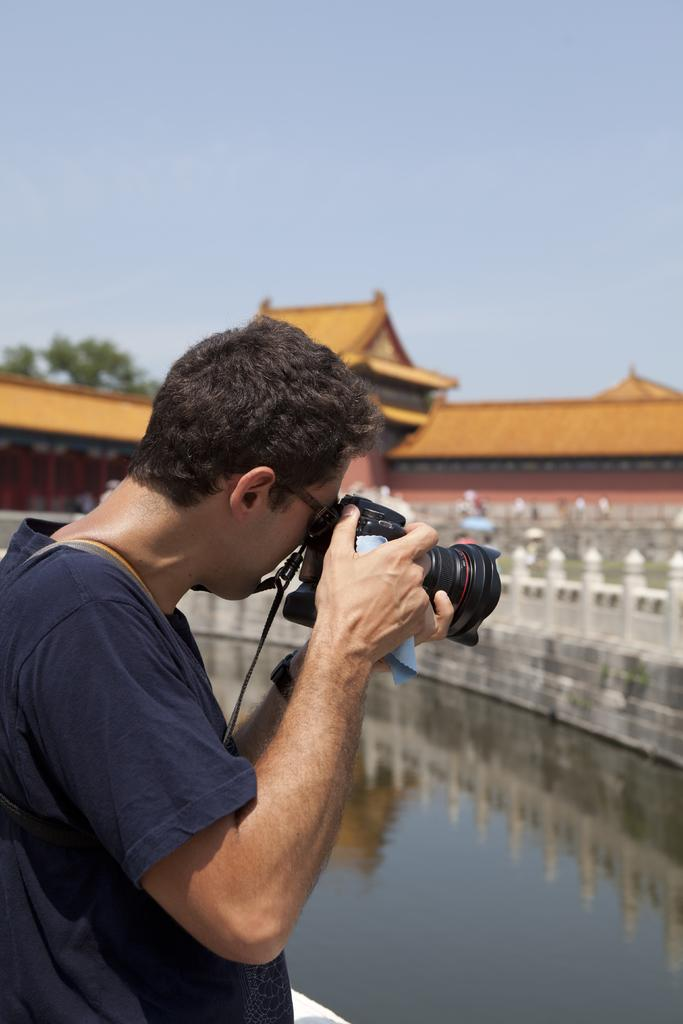What is the person in the image doing? The person is taking a picture. What can be seen in the background of the image? There is a building, water, a tree, and the sky visible in the background of the image. What type of legal advice is the person in the image seeking from a lawyer? There is no indication in the image that the person is seeking legal advice or interacting with a lawyer. 